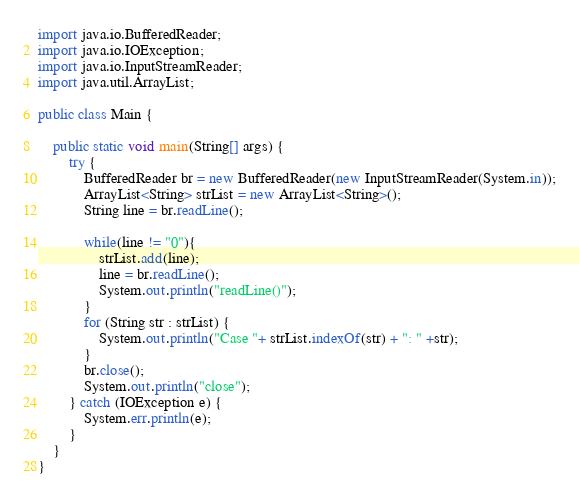Convert code to text. <code><loc_0><loc_0><loc_500><loc_500><_Java_>import java.io.BufferedReader;
import java.io.IOException;
import java.io.InputStreamReader;
import java.util.ArrayList;

public class Main {

    public static void main(String[] args) {
        try {
            BufferedReader br = new BufferedReader(new InputStreamReader(System.in));
            ArrayList<String> strList = new ArrayList<String>();
            String line = br.readLine();
            
            while(line != "0"){
            	strList.add(line);
                line = br.readLine();
                System.out.println("readLine()");
            }
            for (String str : strList) {
            	System.out.println("Case "+ strList.indexOf(str) + ": " +str);
			}
            br.close();
            System.out.println("close");
        } catch (IOException e) {
            System.err.println(e);
        }
    }
}</code> 